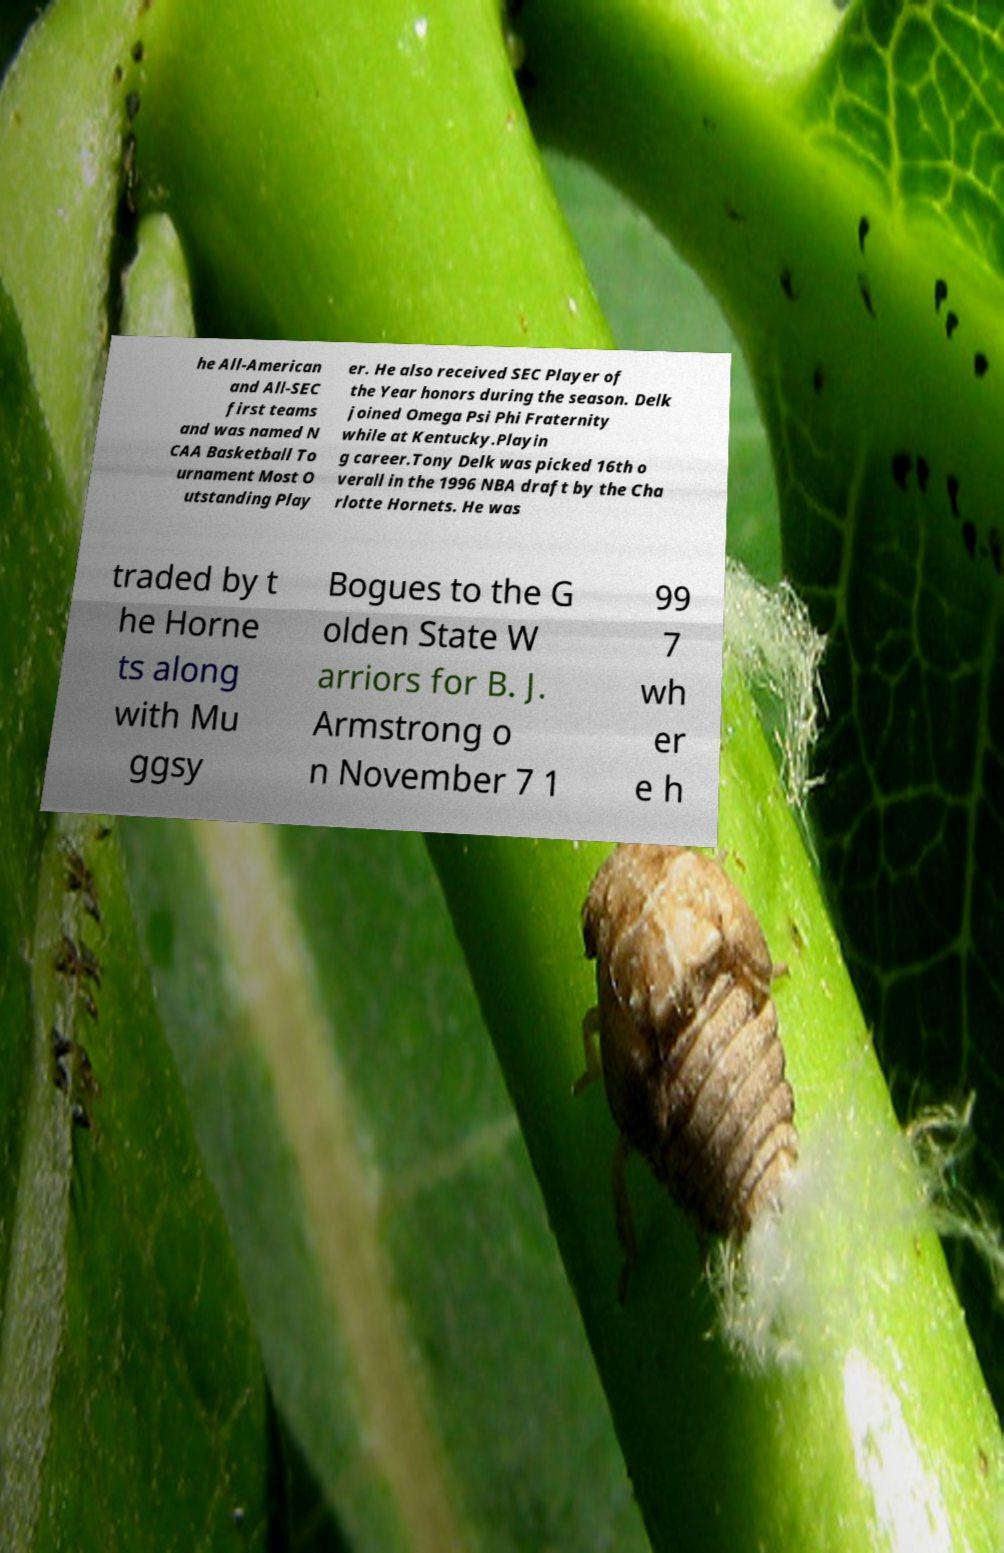Could you assist in decoding the text presented in this image and type it out clearly? he All-American and All-SEC first teams and was named N CAA Basketball To urnament Most O utstanding Play er. He also received SEC Player of the Year honors during the season. Delk joined Omega Psi Phi Fraternity while at Kentucky.Playin g career.Tony Delk was picked 16th o verall in the 1996 NBA draft by the Cha rlotte Hornets. He was traded by t he Horne ts along with Mu ggsy Bogues to the G olden State W arriors for B. J. Armstrong o n November 7 1 99 7 wh er e h 